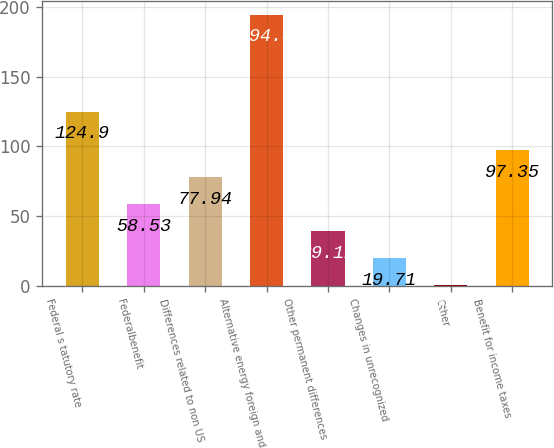Convert chart. <chart><loc_0><loc_0><loc_500><loc_500><bar_chart><fcel>Federal s tatutory rate<fcel>Federalbenefit<fcel>Differences related to non US<fcel>Alternative energy foreign and<fcel>Other permanent differences<fcel>Changes in unrecognized<fcel>Other<fcel>Benefit for income taxes<nl><fcel>124.9<fcel>58.53<fcel>77.94<fcel>194.4<fcel>39.12<fcel>19.71<fcel>0.3<fcel>97.35<nl></chart> 